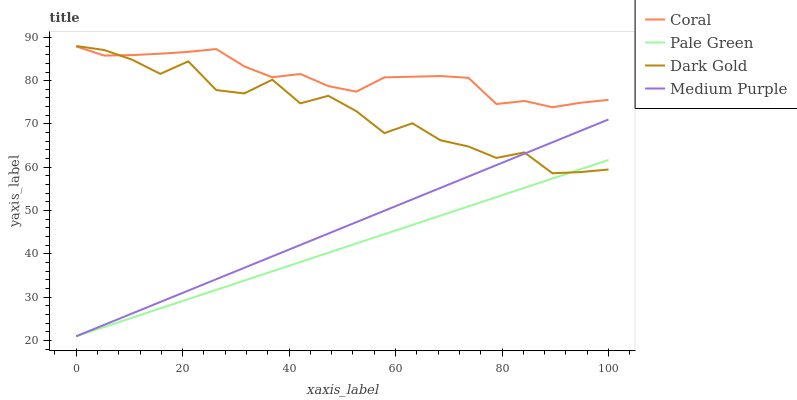Does Coral have the minimum area under the curve?
Answer yes or no. No. Does Pale Green have the maximum area under the curve?
Answer yes or no. No. Is Coral the smoothest?
Answer yes or no. No. Is Coral the roughest?
Answer yes or no. No. Does Coral have the lowest value?
Answer yes or no. No. Does Coral have the highest value?
Answer yes or no. No. Is Medium Purple less than Coral?
Answer yes or no. Yes. Is Coral greater than Pale Green?
Answer yes or no. Yes. Does Medium Purple intersect Coral?
Answer yes or no. No. 